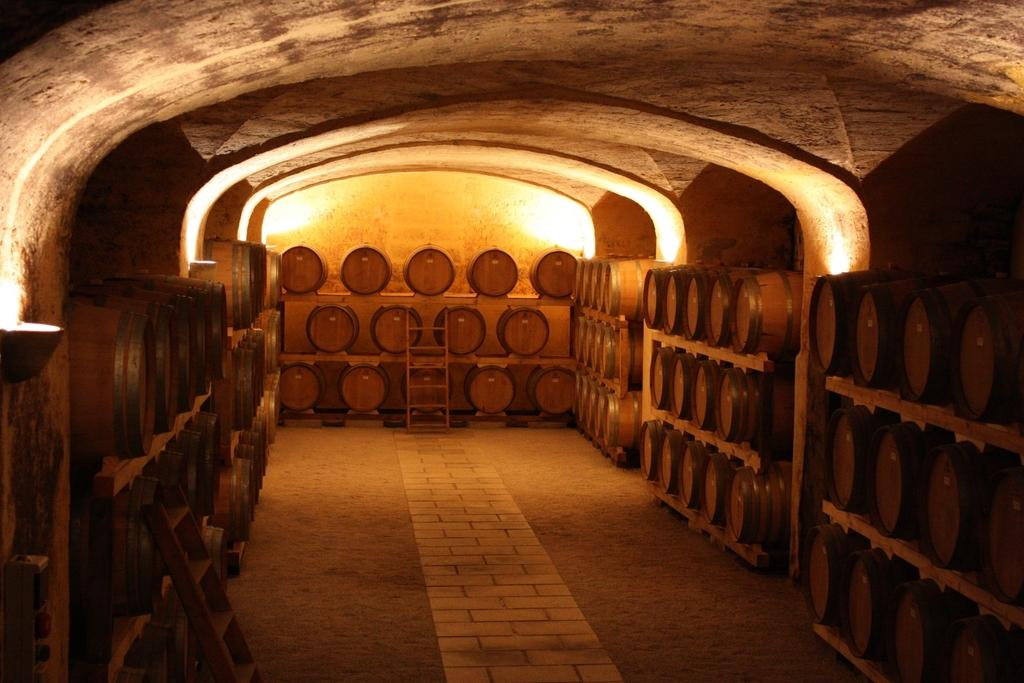What objects can be seen in the image that are used for reaching higher places? There are ladders in the image that are used for reaching higher places. What type of containers are present in the image? There are wooden barrels in the racks in the image. What part of the image represents the ground or surface on which everything else is placed? The floor is visible at the bottom of the image. What type of mist can be seen surrounding the ladders in the image? There is no mist present in the image; the ladders and barrels are clearly visible. What book is being read by the person standing next to the ladders in the image? There is no person or book visible in the image. 